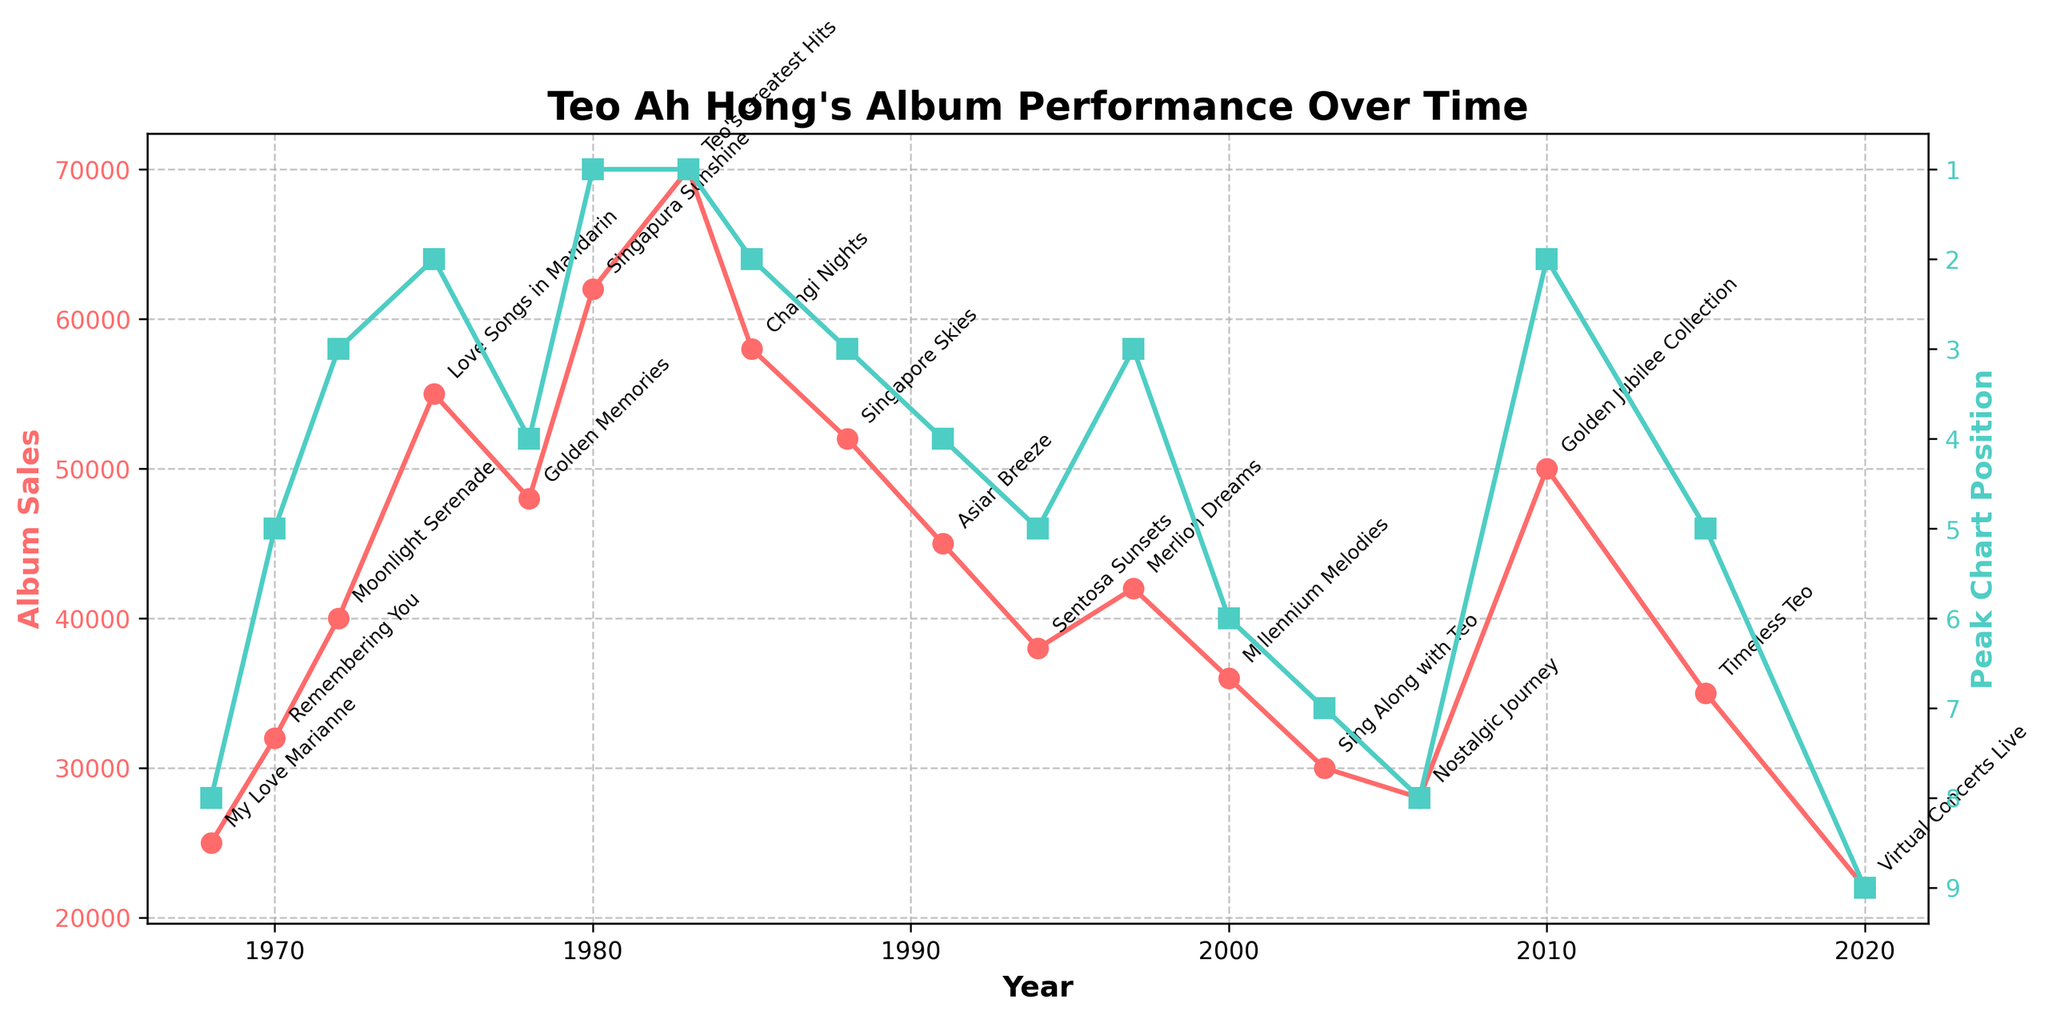How did the album sales trend change from 1980 to 1983? From the plot, album sales increased from 62,000 in 1980 for "Singapura Sunshine" to 70,000 in 1983 for "Teo's Greatest Hits".
Answer: Increased Which album had the highest peak chart position and what was it? "Singapura Sunshine" in 1980 and "Teo's Greatest Hits" in 1983 both reached the highest peak chart position of 1.
Answer: "Singapura Sunshine" and "Teo's Greatest Hits"; Peak Position: 1 Between the albums "Moonlight Serenade" and "Golden Memories," which one had higher sales, and by how much? "Moonlight Serenade" in 1972 had 40,000 sales, while "Golden Memories" in 1978 had 48,000 sales. The difference is 48,000 - 40,000 = 8,000.
Answer: "Golden Memories" by 8,000 What was the trend in peak chart positions from "Asian Breeze" to "Timeless Teo"? Starting from "Asian Breeze" in 1991 (position 4) to "Timeless Teo" in 2015 (position 5), the peak chart positions are as follows: 4, 5, 3, 6, 7, 8, 2, 5. The positions varied but showed a slight increasing trend initially and then peaked again with "Golden Jubilee Collection" before decreasing again.
Answer: Varied with slight increases and peaks Calculate the average sales for albums between 1972 to 1983. The sales are as follows: "Moonlight Serenade" (40,000), "Love Songs in Mandarin" (55,000), "Golden Memories" (48,000), "Singapura Sunshine" (62,000), and "Teo's Greatest Hits" (70,000). The average is (40,000 + 55,000 + 48,000 + 62,000 + 70,000) / 5 = 55,000.
Answer: 55,000 Which album had the lowest sales, and in what year was it released? "Virtual Concerts Live" had the lowest sales of 22,000 and was released in 2020.
Answer: "Virtual Concerts Live" in 2020 Identify the album with the highest sales difference from its predecessor. The difference between "Love Songs in Mandarin" (55,000) in 1975 and "Golden Memories" (48,000) is -7,000. The largest jump is from "Golden Memories" (48,000) released in 1978 to "Singapura Sunshine" (62,000) released in 1980, a difference of 14,000.
Answer: "Singapura Sunshine" with a 14,000 sales increase How many albums had a peak chart position of 1? From the plot, "Singapura Sunshine" in 1980 and "Teo's Greatest Hits" in 1983 had peak chart positions of 1.
Answer: 2 albums 